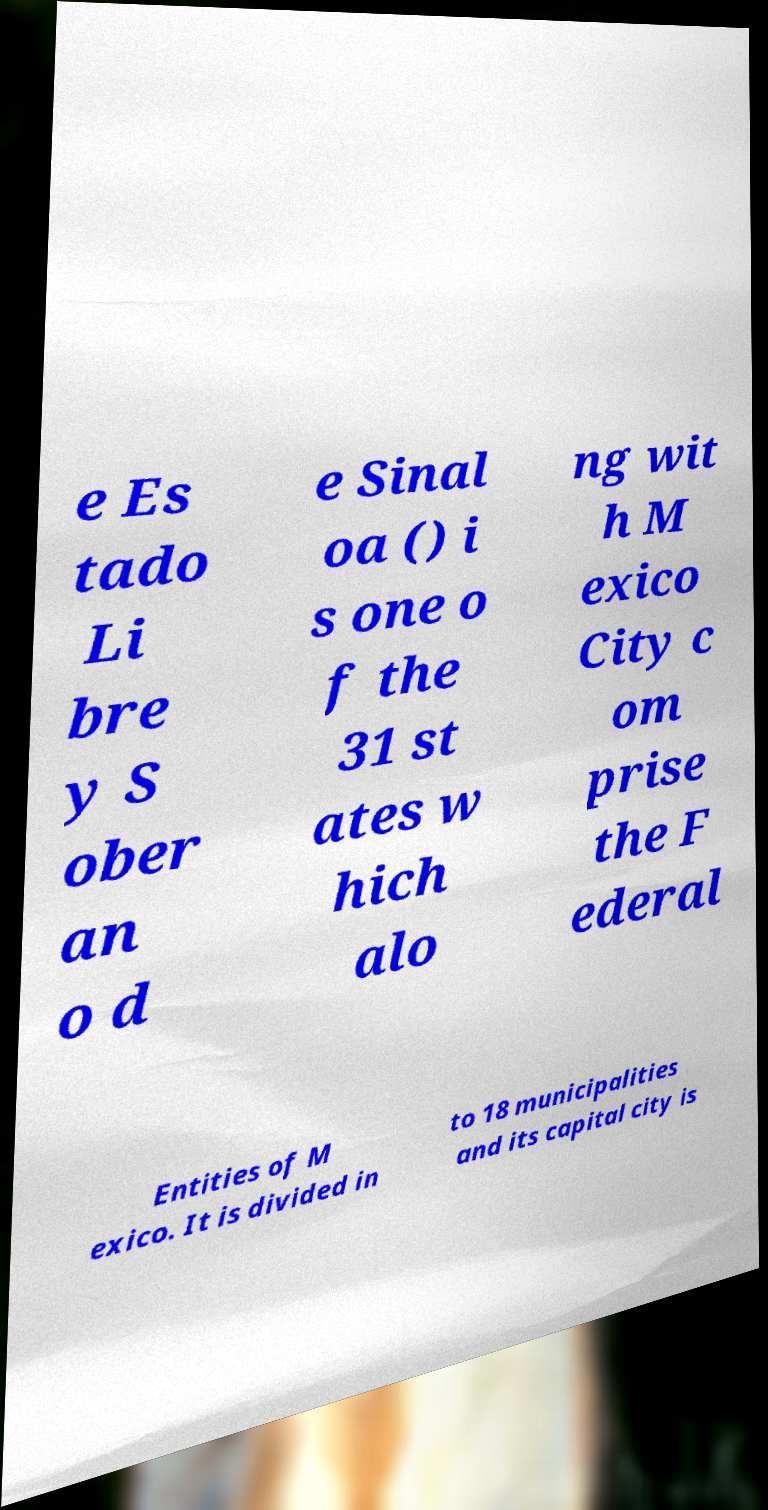Please read and relay the text visible in this image. What does it say? e Es tado Li bre y S ober an o d e Sinal oa () i s one o f the 31 st ates w hich alo ng wit h M exico City c om prise the F ederal Entities of M exico. It is divided in to 18 municipalities and its capital city is 